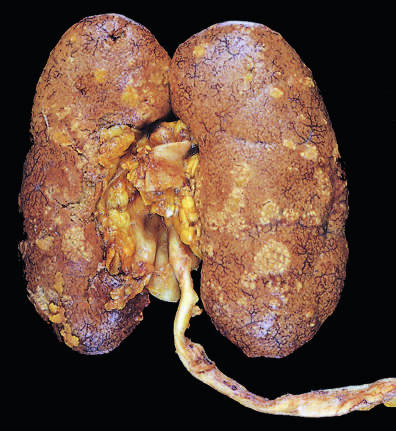what is studded with focal pale abscesses, more numerous in the upper pole and middle region of the kidney?
Answer the question using a single word or phrase. The cortical surface 